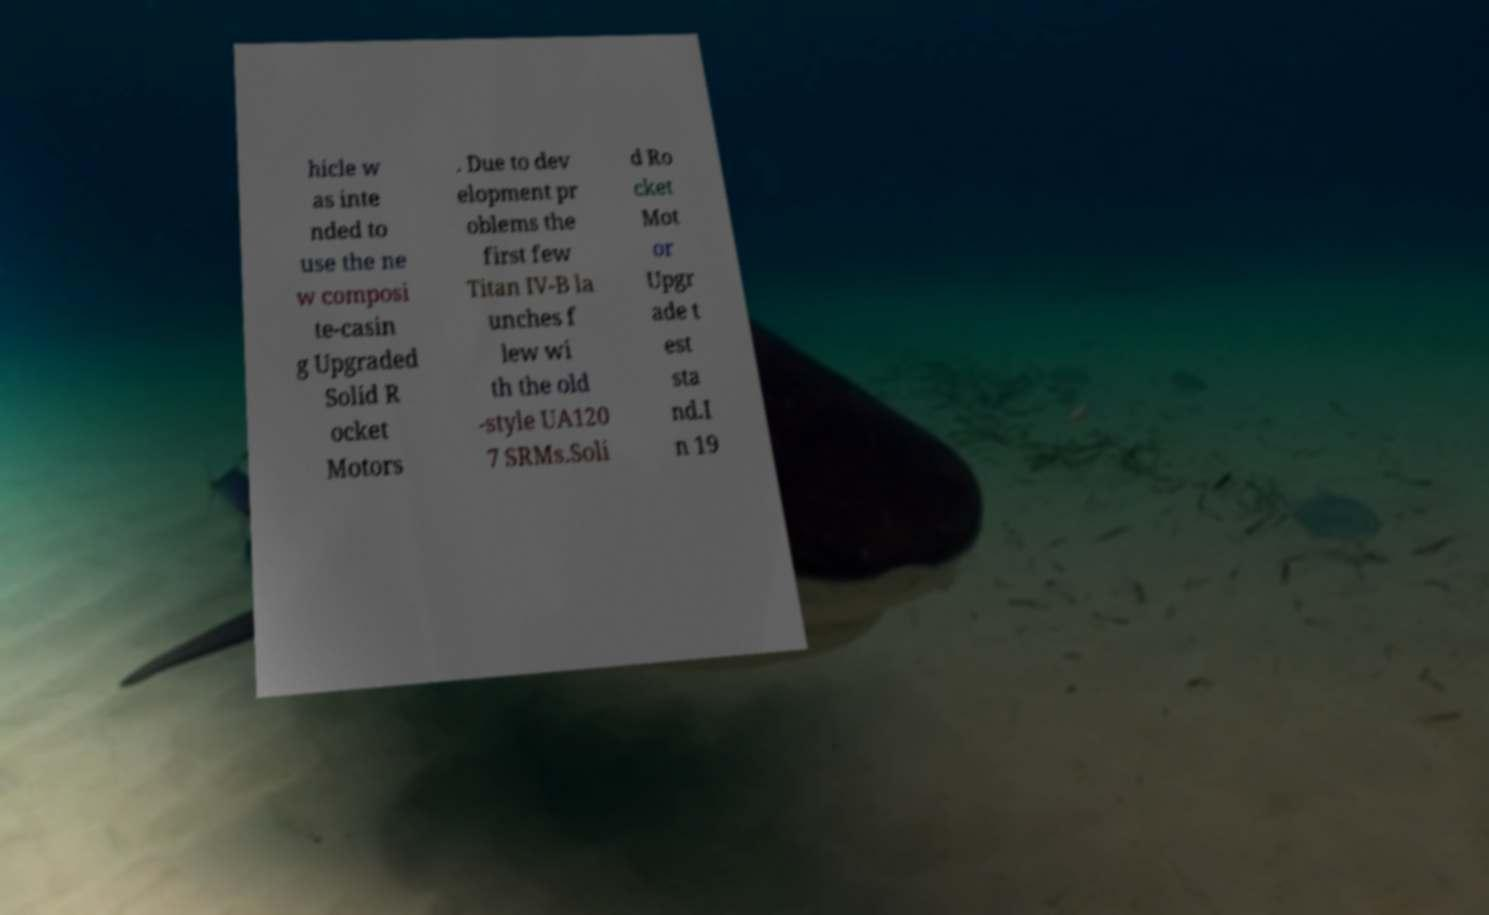Could you extract and type out the text from this image? hicle w as inte nded to use the ne w composi te-casin g Upgraded Solid R ocket Motors . Due to dev elopment pr oblems the first few Titan IV-B la unches f lew wi th the old -style UA120 7 SRMs.Soli d Ro cket Mot or Upgr ade t est sta nd.I n 19 